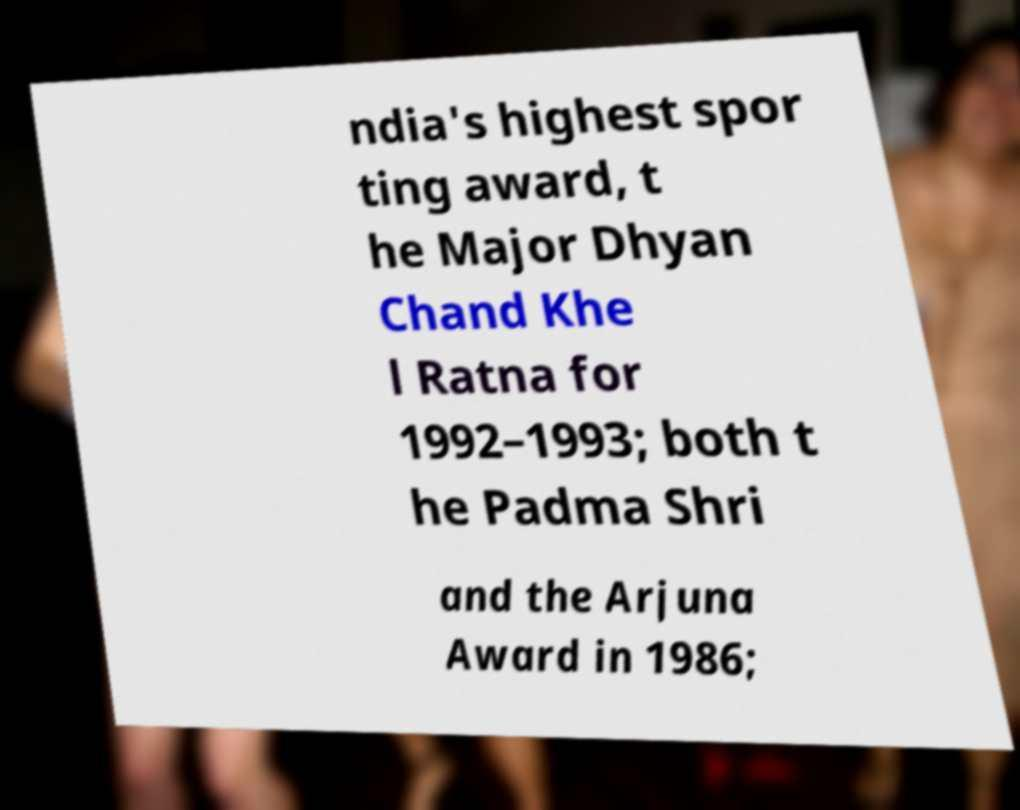There's text embedded in this image that I need extracted. Can you transcribe it verbatim? ndia's highest spor ting award, t he Major Dhyan Chand Khe l Ratna for 1992–1993; both t he Padma Shri and the Arjuna Award in 1986; 